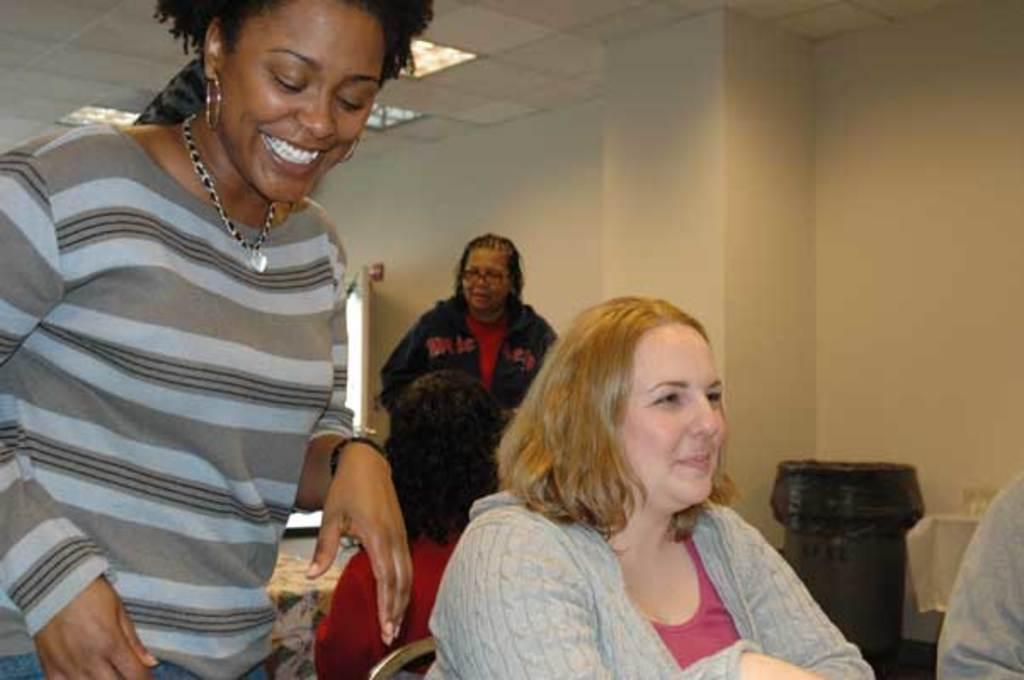Please provide a concise description of this image. In this image, we can see few people. Few are sitting and standing. Here we can see few women are smiling. Background we can see a wall, dustbin, cloth, some objects. Top of the image, there is a roof with lights. 